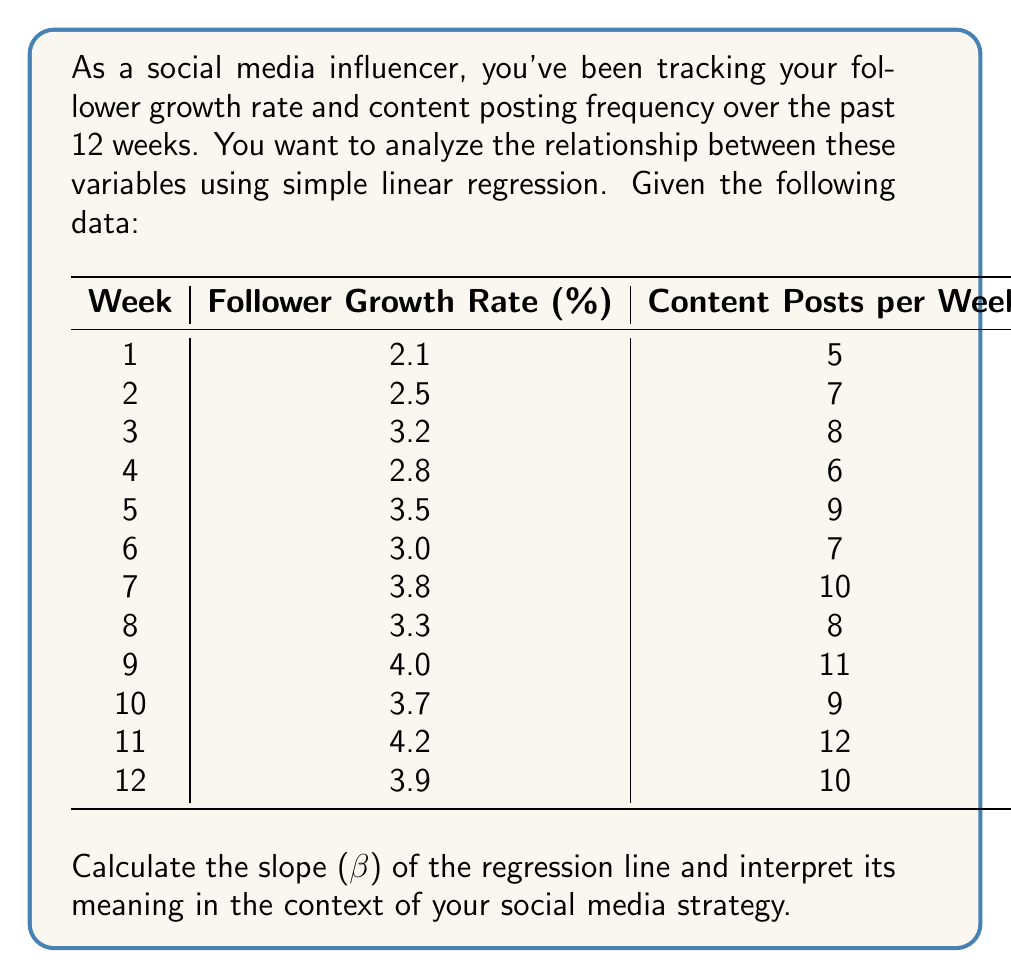Could you help me with this problem? To calculate the slope (β) of the regression line, we'll use the formula:

$$ \beta = \frac{n\sum xy - \sum x \sum y}{n\sum x^2 - (\sum x)^2} $$

Where:
- n is the number of data points (12 weeks)
- x represents the Content Posts per Week
- y represents the Follower Growth Rate (%)

Let's calculate the necessary components:

1. $\sum x = 102$ (sum of Content Posts per Week)
2. $\sum y = 40$ (sum of Follower Growth Rates)
3. $\sum xy = 349.8$ (sum of products of x and y)
4. $\sum x^2 = 902$ (sum of squared Content Posts)
5. $(\sum x)^2 = 10,404$

Now, let's substitute these values into the formula:

$$ \beta = \frac{12(349.8) - 102(40)}{12(902) - 10,404} $$

$$ \beta = \frac{4197.6 - 4080}{10,824 - 10,404} $$

$$ \beta = \frac{117.6}{420} $$

$$ \beta = 0.28 $$

The slope (β) of the regression line is 0.28.

Interpretation: For each additional content post per week, the follower growth rate is expected to increase by 0.28 percentage points, on average. This positive slope indicates a positive correlation between content posting frequency and follower growth rate.
Answer: The slope (β) of the regression line is 0.28, indicating that for each additional content post per week, the follower growth rate is expected to increase by 0.28 percentage points, on average. 